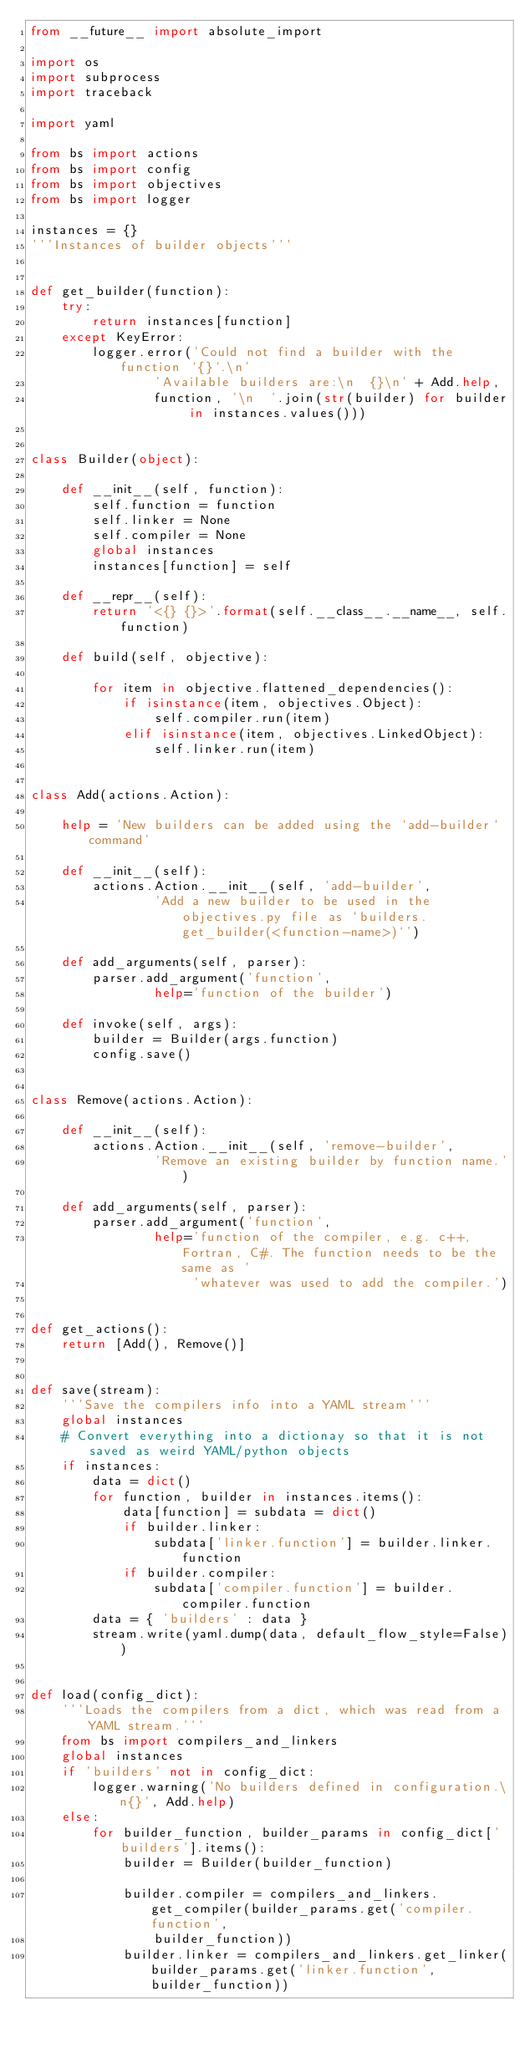<code> <loc_0><loc_0><loc_500><loc_500><_Python_>from __future__ import absolute_import

import os
import subprocess
import traceback

import yaml

from bs import actions
from bs import config
from bs import objectives
from bs import logger

instances = {}
'''Instances of builder objects'''


def get_builder(function):
    try:
        return instances[function]
    except KeyError:
        logger.error('Could not find a builder with the function `{}`.\n'
                'Available builders are:\n  {}\n' + Add.help,
                function, '\n  '.join(str(builder) for builder in instances.values()))


class Builder(object):

    def __init__(self, function):
        self.function = function
        self.linker = None
        self.compiler = None
        global instances
        instances[function] = self

    def __repr__(self):
        return '<{} {}>'.format(self.__class__.__name__, self.function)

    def build(self, objective):

        for item in objective.flattened_dependencies():
            if isinstance(item, objectives.Object):
                self.compiler.run(item)
            elif isinstance(item, objectives.LinkedObject):
                self.linker.run(item)


class Add(actions.Action):

    help = 'New builders can be added using the `add-builder` command'

    def __init__(self):
        actions.Action.__init__(self, 'add-builder',
                'Add a new builder to be used in the objectives.py file as `builders.get_builder(<function-name>)`')

    def add_arguments(self, parser):
        parser.add_argument('function',
                help='function of the builder')

    def invoke(self, args):
        builder = Builder(args.function)
        config.save()


class Remove(actions.Action):

    def __init__(self):
        actions.Action.__init__(self, 'remove-builder',
                'Remove an existing builder by function name.')

    def add_arguments(self, parser):
        parser.add_argument('function',
                help='function of the compiler, e.g. c++, Fortran, C#. The function needs to be the same as '
                     'whatever was used to add the compiler.')


def get_actions():
    return [Add(), Remove()]


def save(stream):
    '''Save the compilers info into a YAML stream'''
    global instances
    # Convert everything into a dictionay so that it is not saved as weird YAML/python objects
    if instances:
        data = dict()
        for function, builder in instances.items():
            data[function] = subdata = dict()
            if builder.linker:
                subdata['linker.function'] = builder.linker.function
            if builder.compiler:
                subdata['compiler.function'] = builder.compiler.function
        data = { 'builders' : data }
        stream.write(yaml.dump(data, default_flow_style=False))


def load(config_dict):
    '''Loads the compilers from a dict, which was read from a YAML stream.'''
    from bs import compilers_and_linkers
    global instances
    if 'builders' not in config_dict:
        logger.warning('No builders defined in configuration.\n{}', Add.help)
    else:
        for builder_function, builder_params in config_dict['builders'].items():
            builder = Builder(builder_function)
            
            builder.compiler = compilers_and_linkers.get_compiler(builder_params.get('compiler.function',
                builder_function))
            builder.linker = compilers_and_linkers.get_linker(builder_params.get('linker.function', builder_function))



</code> 